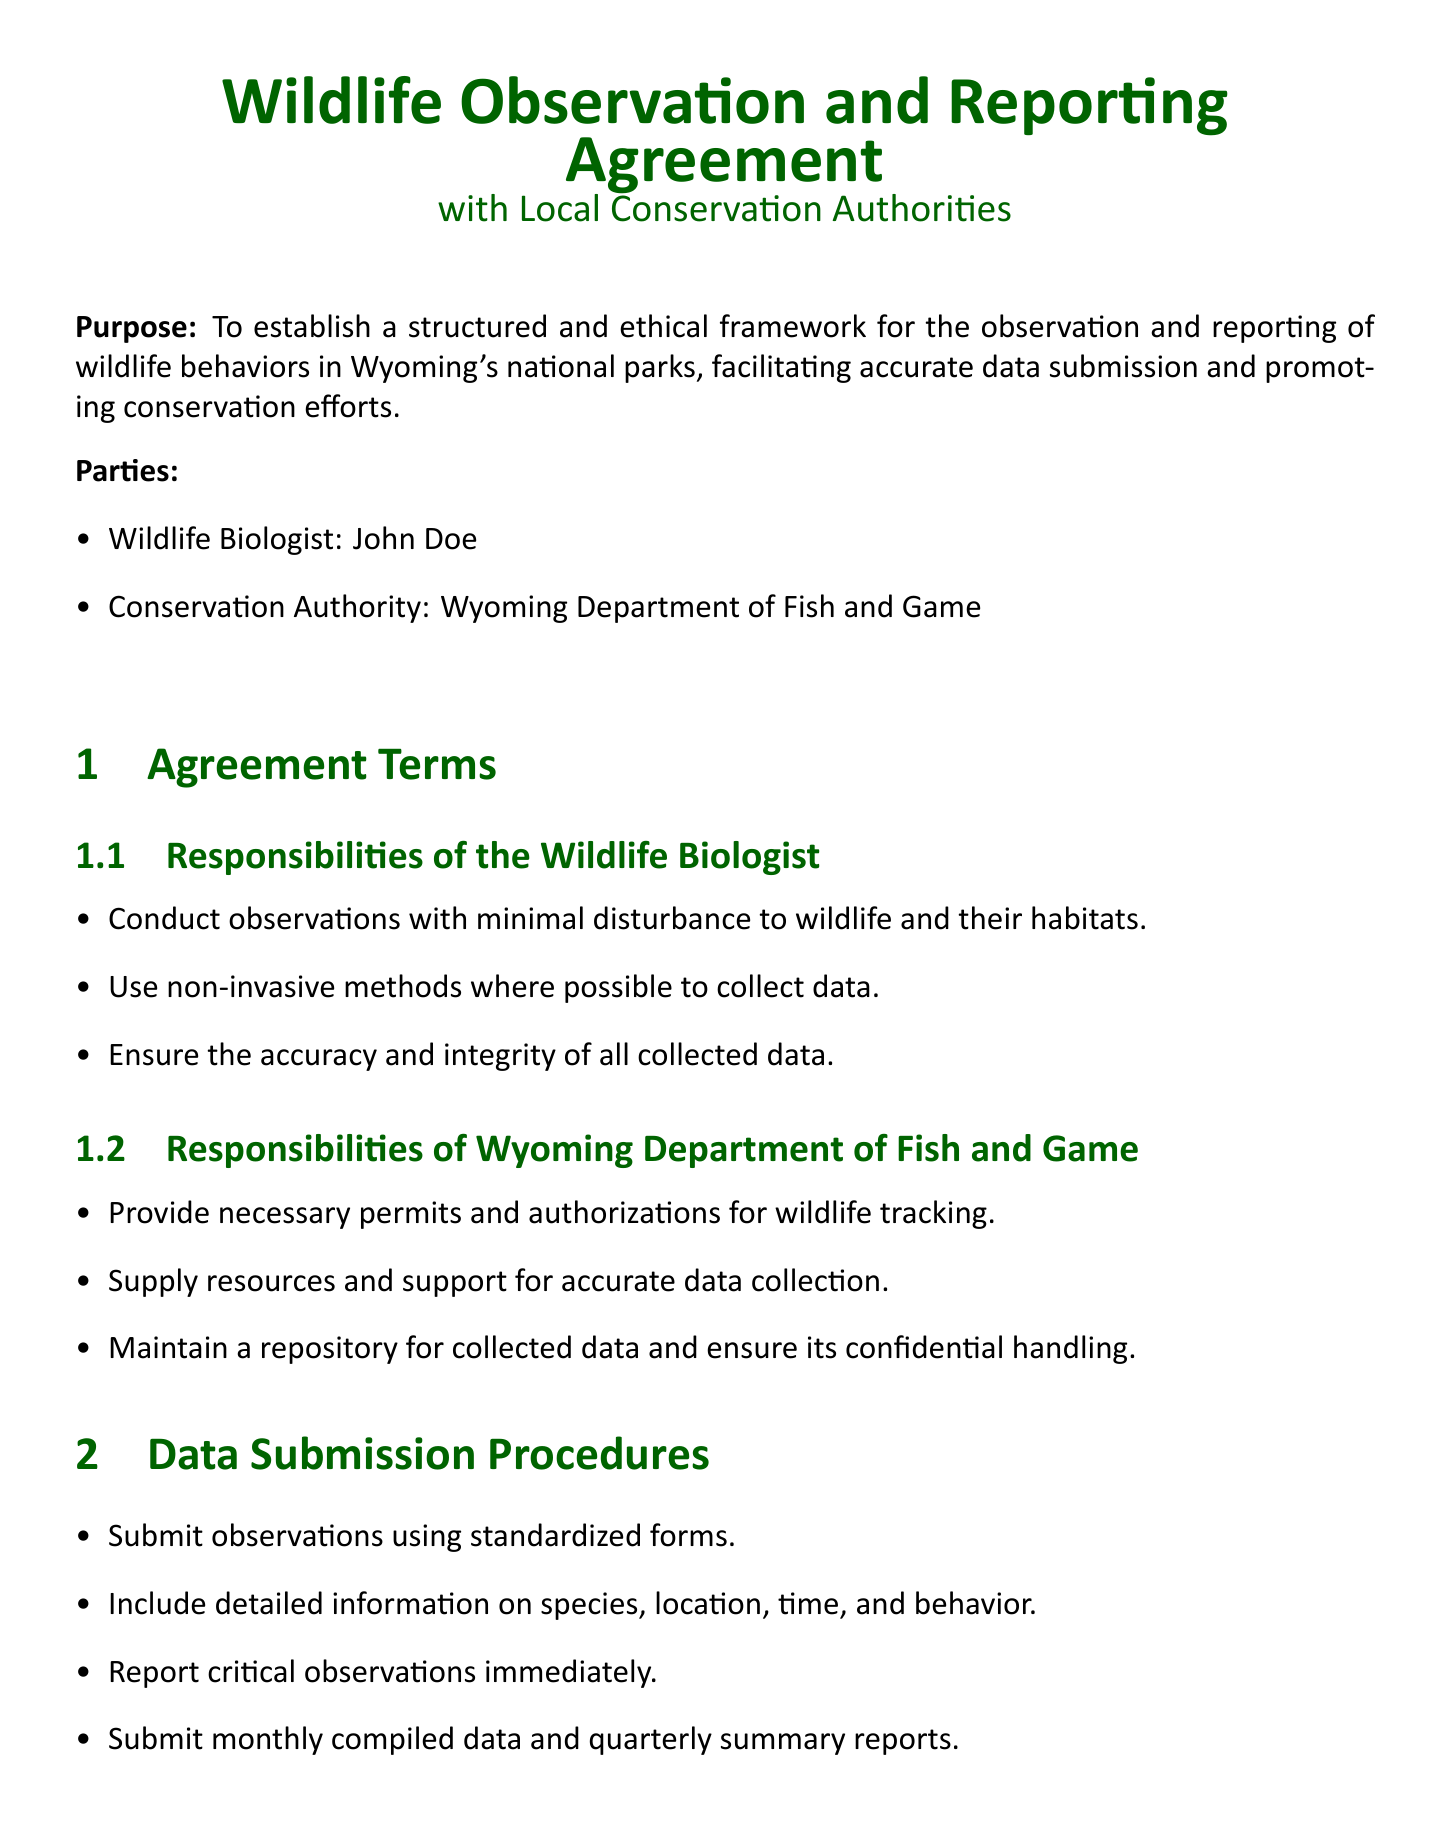What is the title of the document? The title is clearly stated at the beginning of the document.
Answer: Wildlife Observation and Reporting Agreement Who is the wildlife biologist named in the document? The wildlife biologist is listed in the parties section of the document.
Answer: John Doe What is the conservation authority mentioned? The conservation authority is specified in the parties section of the document.
Answer: Wyoming Department of Fish and Game What is the submission frequency for compiled data? The document specifies a timeline for submitting compiled data.
Answer: Monthly What is one key responsibility of the wildlife biologist? The document lists several responsibilities for the wildlife biologist.
Answer: Conduct observations with minimal disturbance What is one of the ethical guidelines outlined? The document contains a section on ethical guidelines.
Answer: Adhere to ethical standards for wildlife observation What type of methods should be used for data collection? The responsibilities section indicates the preferred approach for data collection.
Answer: Non-invasive methods When should critical observations be reported? The data submission procedures include a specific timeline for reporting.
Answer: Immediately What must be included in the standardized forms for observation submissions? The document outlines specific details required in the submission forms.
Answer: Detailed information on species, location, time, and behavior 